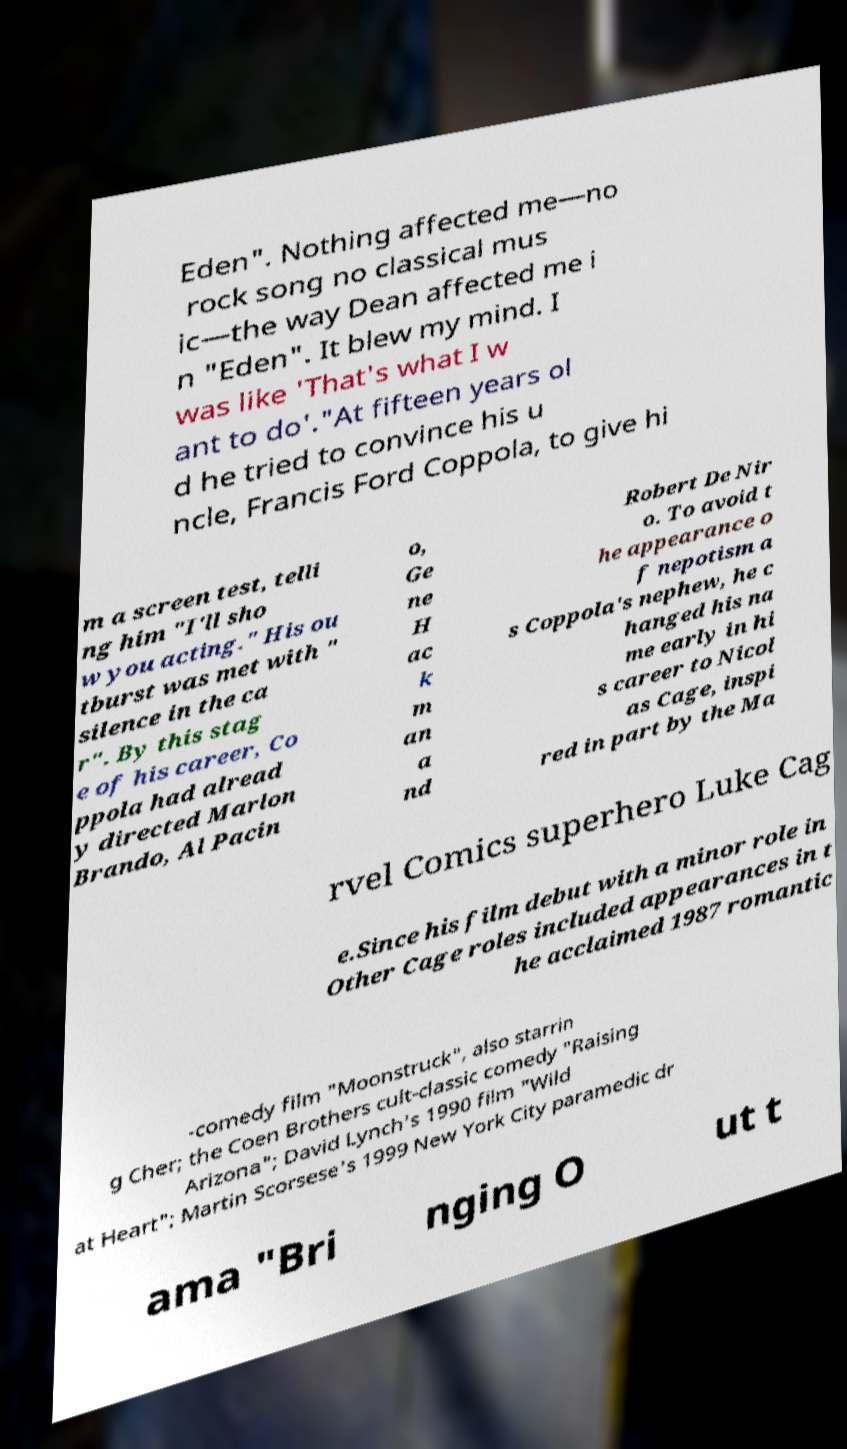Can you read and provide the text displayed in the image?This photo seems to have some interesting text. Can you extract and type it out for me? Eden". Nothing affected me—no rock song no classical mus ic—the way Dean affected me i n "Eden". It blew my mind. I was like 'That's what I w ant to do'."At fifteen years ol d he tried to convince his u ncle, Francis Ford Coppola, to give hi m a screen test, telli ng him "I'll sho w you acting." His ou tburst was met with " silence in the ca r". By this stag e of his career, Co ppola had alread y directed Marlon Brando, Al Pacin o, Ge ne H ac k m an a nd Robert De Nir o. To avoid t he appearance o f nepotism a s Coppola's nephew, he c hanged his na me early in hi s career to Nicol as Cage, inspi red in part by the Ma rvel Comics superhero Luke Cag e.Since his film debut with a minor role in Other Cage roles included appearances in t he acclaimed 1987 romantic -comedy film "Moonstruck", also starrin g Cher; the Coen Brothers cult-classic comedy "Raising Arizona"; David Lynch's 1990 film "Wild at Heart"; Martin Scorsese's 1999 New York City paramedic dr ama "Bri nging O ut t 